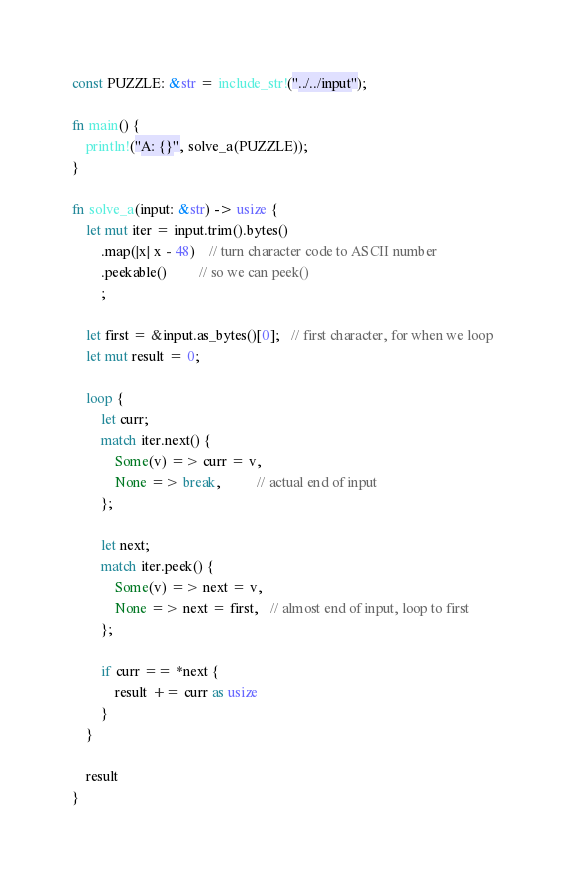<code> <loc_0><loc_0><loc_500><loc_500><_Rust_>const PUZZLE: &str = include_str!("../../input");

fn main() {
    println!("A: {}", solve_a(PUZZLE));
}

fn solve_a(input: &str) -> usize {
    let mut iter = input.trim().bytes()
        .map(|x| x - 48)    // turn character code to ASCII number
        .peekable()         // so we can peek()
        ;

    let first = &input.as_bytes()[0];   // first character, for when we loop
    let mut result = 0;

    loop {
        let curr;
        match iter.next() {
            Some(v) => curr = v,
            None => break,          // actual end of input
        };

        let next;
        match iter.peek() {
            Some(v) => next = v,
            None => next = first,   // almost end of input, loop to first
        };

        if curr == *next {
            result += curr as usize
        }
    }

    result
}
</code> 